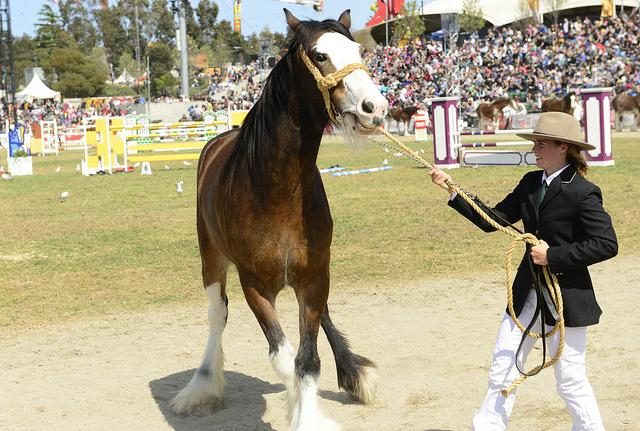What is it called when this animal moves? Please explain your reasoning. trot. The horse trots. 